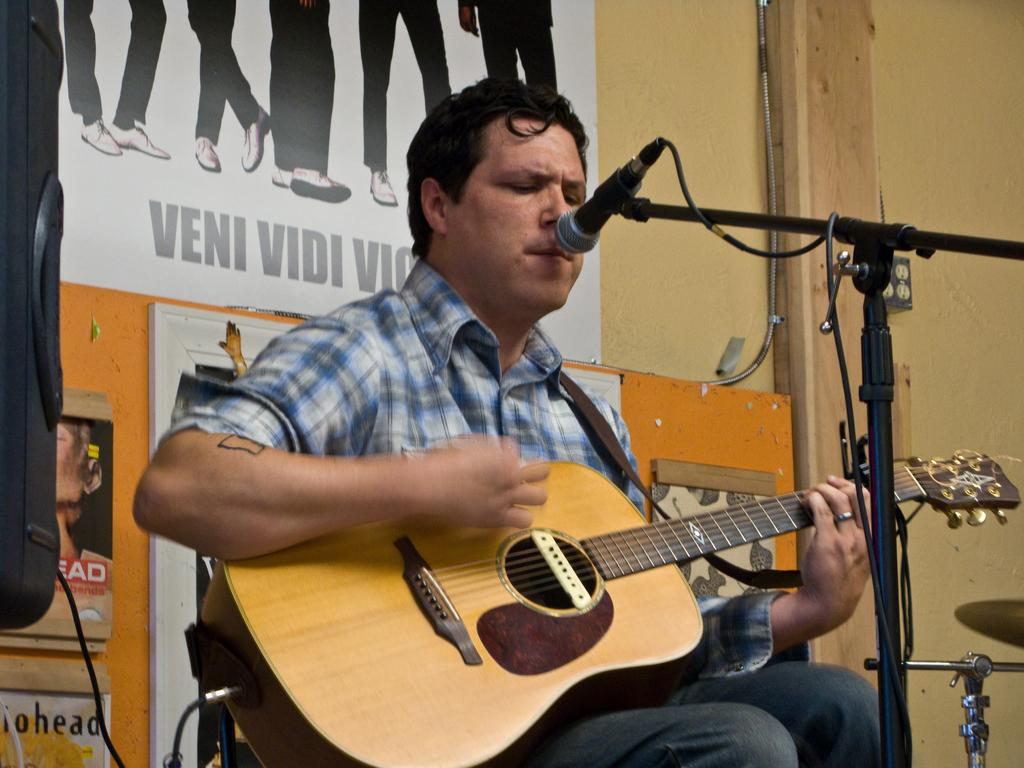What is the main subject of the image? There is a person in the image. What is the person doing in the image? The person is sitting on a chair and singing on a microphone. What object is the person holding in the image? The person is holding a guitar in the image. What type of shirt is the person wearing during their dinner with planes? There is no mention of a shirt, dinner, or planes in the image. The person is wearing a microphone and holding a guitar while sitting on a chair and singing. 